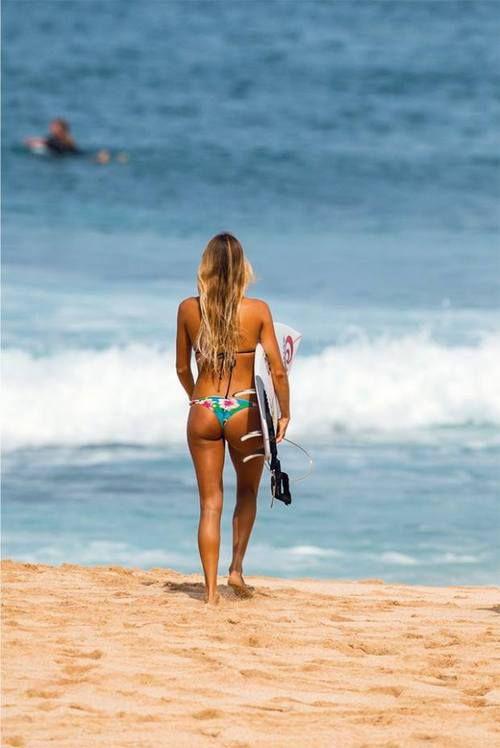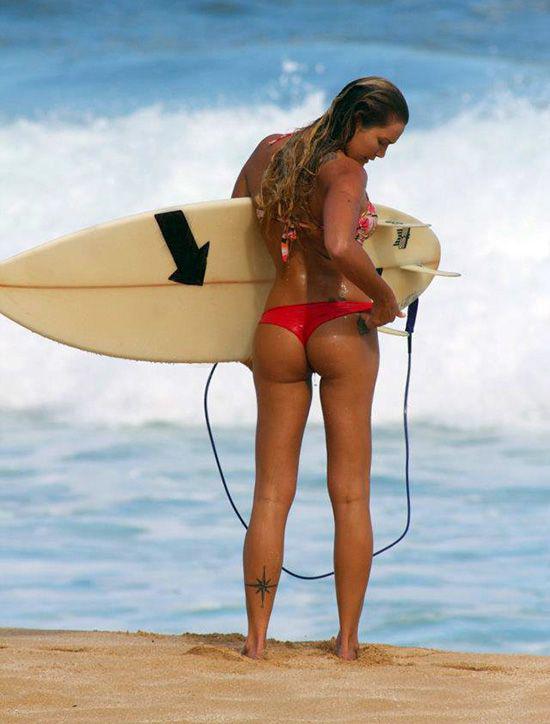The first image is the image on the left, the second image is the image on the right. Analyze the images presented: Is the assertion "An image shows just one bikini model facing the ocean and holding a surfboard on the right side." valid? Answer yes or no. Yes. 